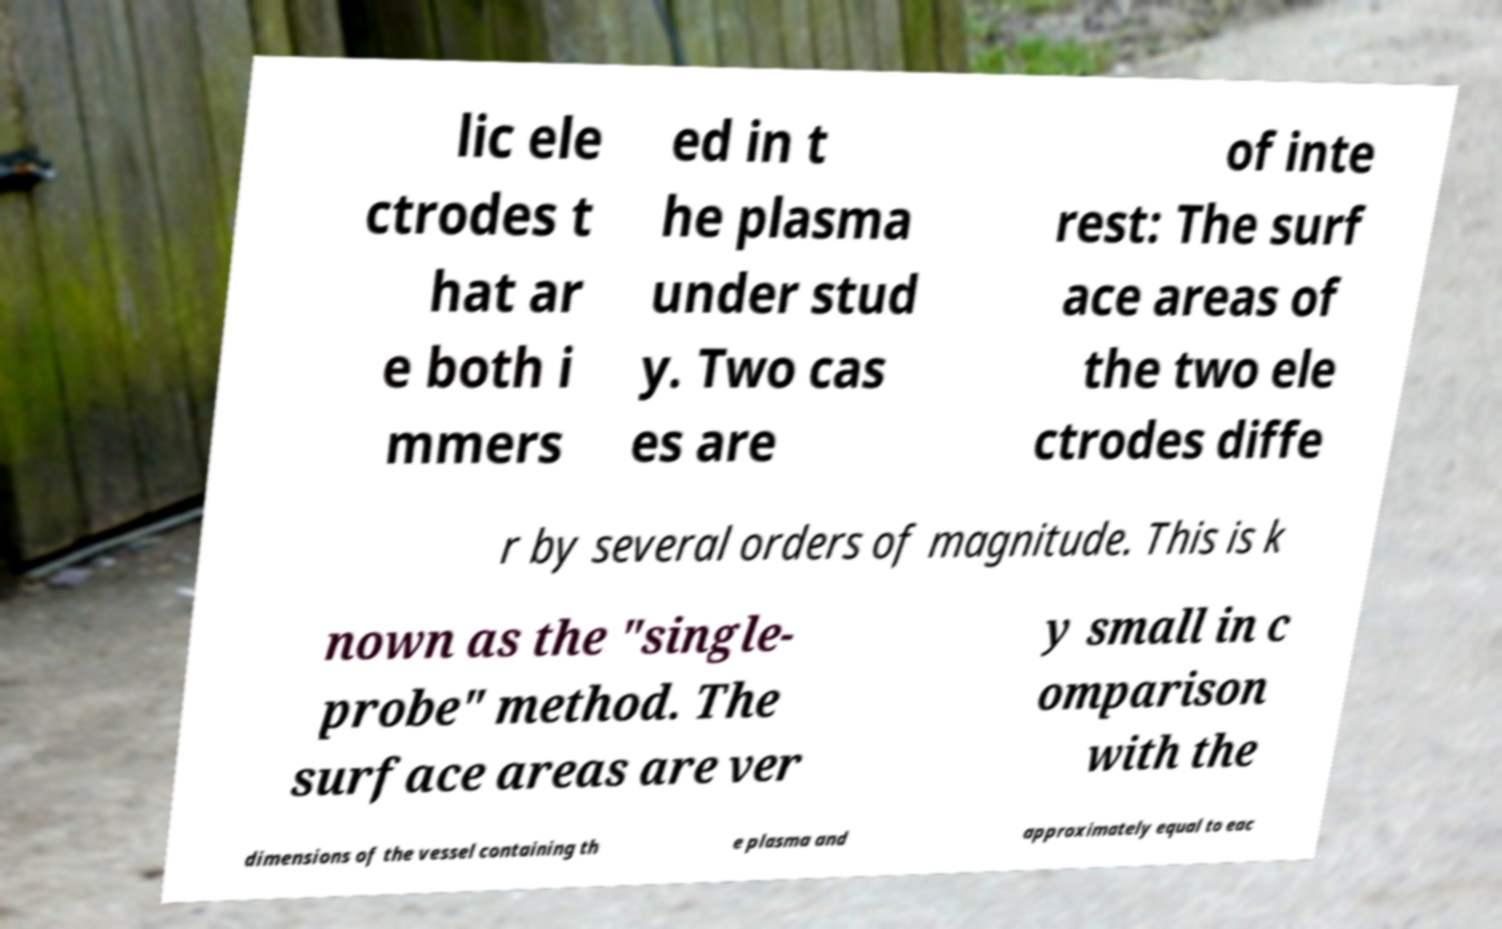Please identify and transcribe the text found in this image. lic ele ctrodes t hat ar e both i mmers ed in t he plasma under stud y. Two cas es are of inte rest: The surf ace areas of the two ele ctrodes diffe r by several orders of magnitude. This is k nown as the "single- probe" method. The surface areas are ver y small in c omparison with the dimensions of the vessel containing th e plasma and approximately equal to eac 